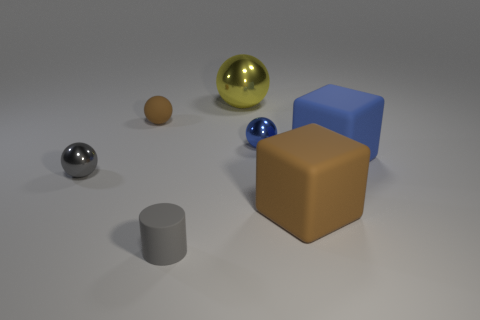Add 1 tiny objects. How many objects exist? 8 Subtract all small gray balls. How many balls are left? 3 Subtract all cubes. How many objects are left? 5 Subtract all blue spheres. How many spheres are left? 3 Add 3 shiny balls. How many shiny balls are left? 6 Add 3 tiny red metallic balls. How many tiny red metallic balls exist? 3 Subtract 0 purple balls. How many objects are left? 7 Subtract all green cubes. Subtract all gray cylinders. How many cubes are left? 2 Subtract all large gray matte spheres. Subtract all small blue shiny objects. How many objects are left? 6 